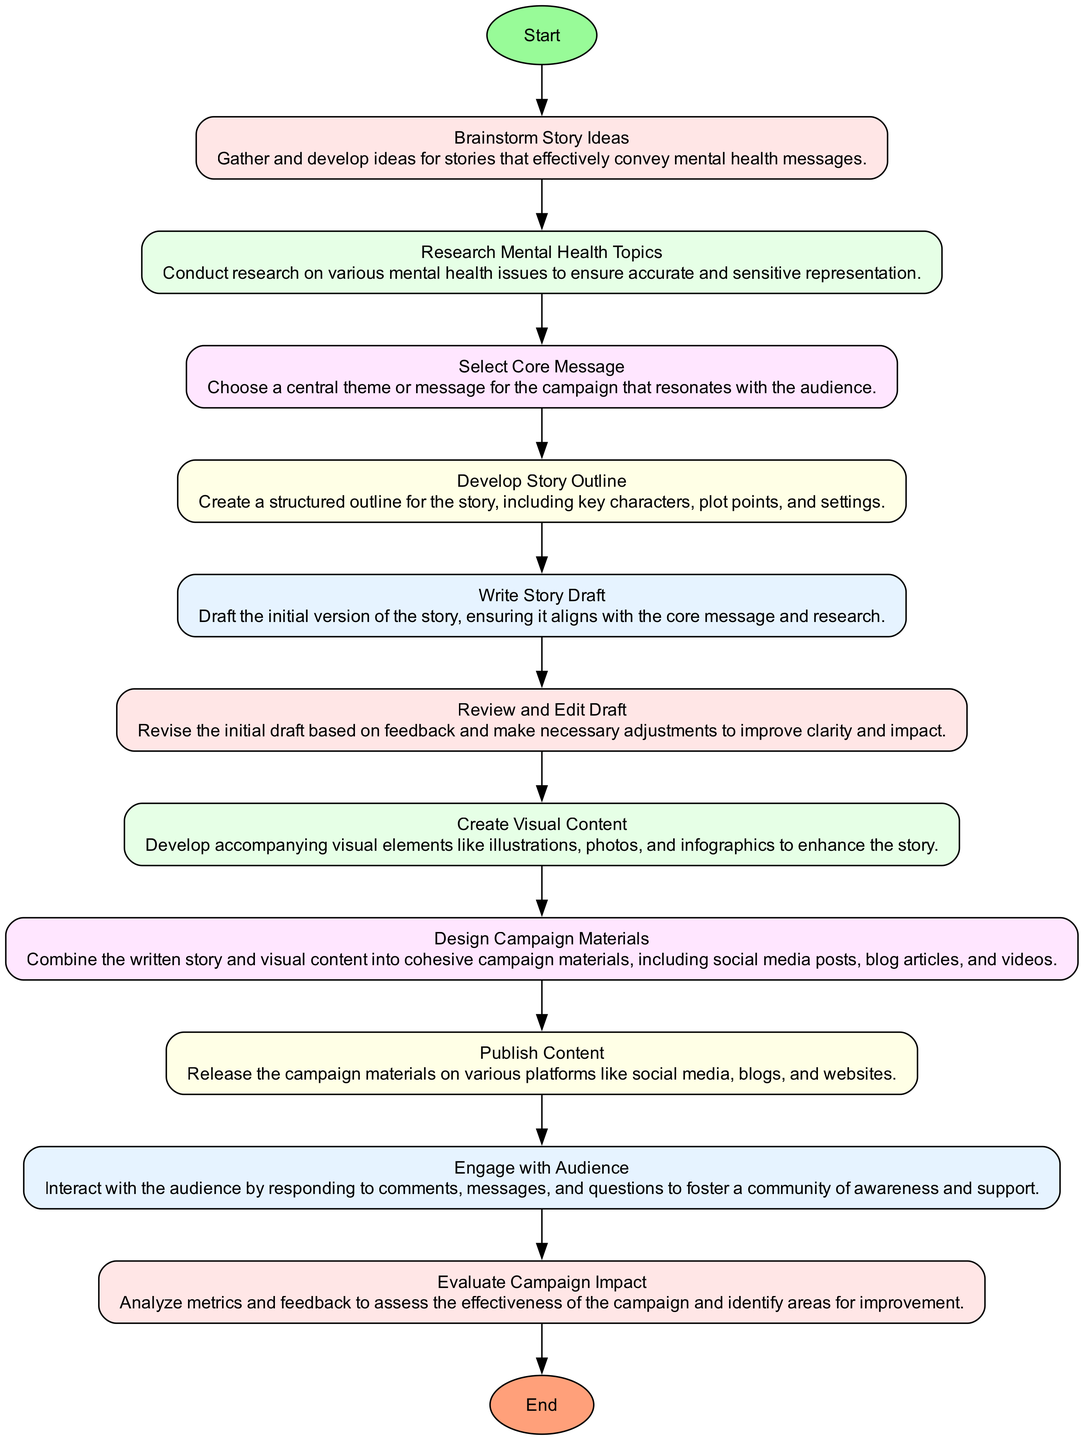What is the first activity in the process? The first activity listed in the diagram is "Brainstorm Story Ideas." This is found as the second element in the list of activities, immediately following the Start node.
Answer: Brainstorm Story Ideas How many activities are there in total? By counting all the activities listed between the Start and End nodes, there are a total of 10 activities.
Answer: 10 What comes immediately after "Select Core Message"? The next activity in the flow after "Select Core Message" is "Develop Story Outline," which follows it in the sequence of the diagram.
Answer: Develop Story Outline Which activity involves creating visual elements? The activity "Create Visual Content" addresses the development of visual elements like illustrations, photos, and infographics. It is clearly defined as an activity after "Review and Edit Draft."
Answer: Create Visual Content What is the main purpose of "Evaluate Campaign Impact"? The purpose of this activity is to analyze metrics and feedback to assess the effectiveness of the campaign. It is the second-to-last activity before reaching the End node in the flow.
Answer: Analyze metrics and feedback What do the nodes represent in this diagram? In this activity diagram, the nodes represent distinct activities or milestones in the process of developing a mental health awareness campaign. Each node is connected by directed edges that indicate the flow from one activity to the next.
Answer: Activities or milestones What is the last activity in the diagram? The final activity before reaching the End node is "Engage with Audience," which emphasizes the importance of interacting with the audience after publishing the content.
Answer: Engage with Audience What relationship exists between "Write Story Draft" and "Review and Edit Draft"? The relationship is sequential; "Write Story Draft" must be completed first, and then the next activity is "Review and Edit Draft." This indicates a flow where writing leads directly into a review process.
Answer: Sequential relationship Which activity is concerned with audience interaction? The activity focused on audience interaction is "Engage with Audience," where the aim is to foster a community of awareness and support after content is published.
Answer: Engage with Audience 